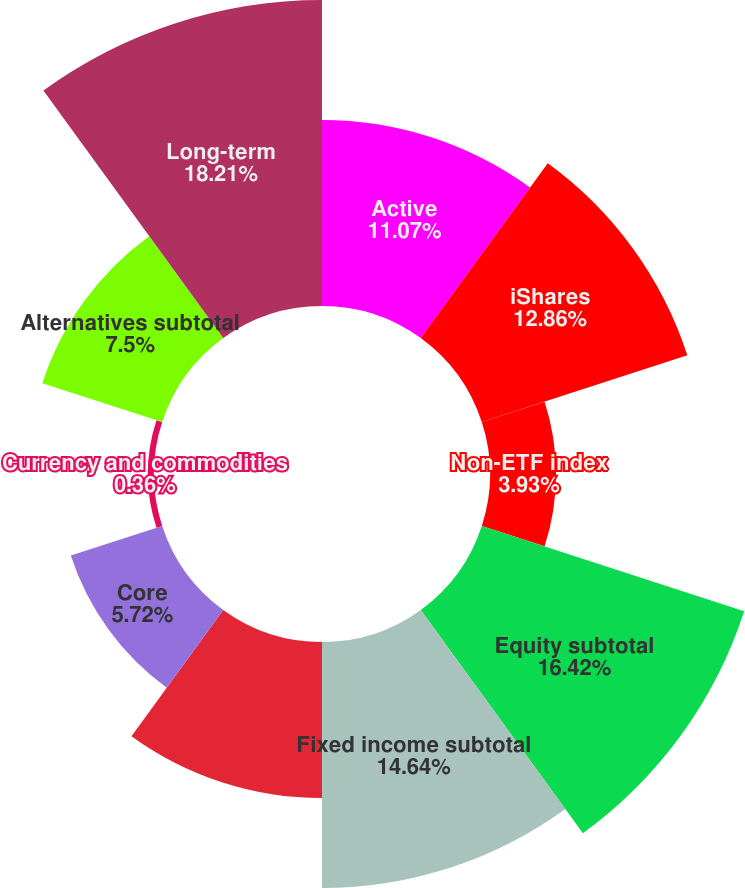Convert chart. <chart><loc_0><loc_0><loc_500><loc_500><pie_chart><fcel>Active<fcel>iShares<fcel>Non-ETF index<fcel>Equity subtotal<fcel>Fixed income subtotal<fcel>Multi-asset<fcel>Core<fcel>Currency and commodities<fcel>Alternatives subtotal<fcel>Long-term<nl><fcel>11.07%<fcel>12.86%<fcel>3.93%<fcel>16.42%<fcel>14.64%<fcel>9.29%<fcel>5.72%<fcel>0.36%<fcel>7.5%<fcel>18.21%<nl></chart> 